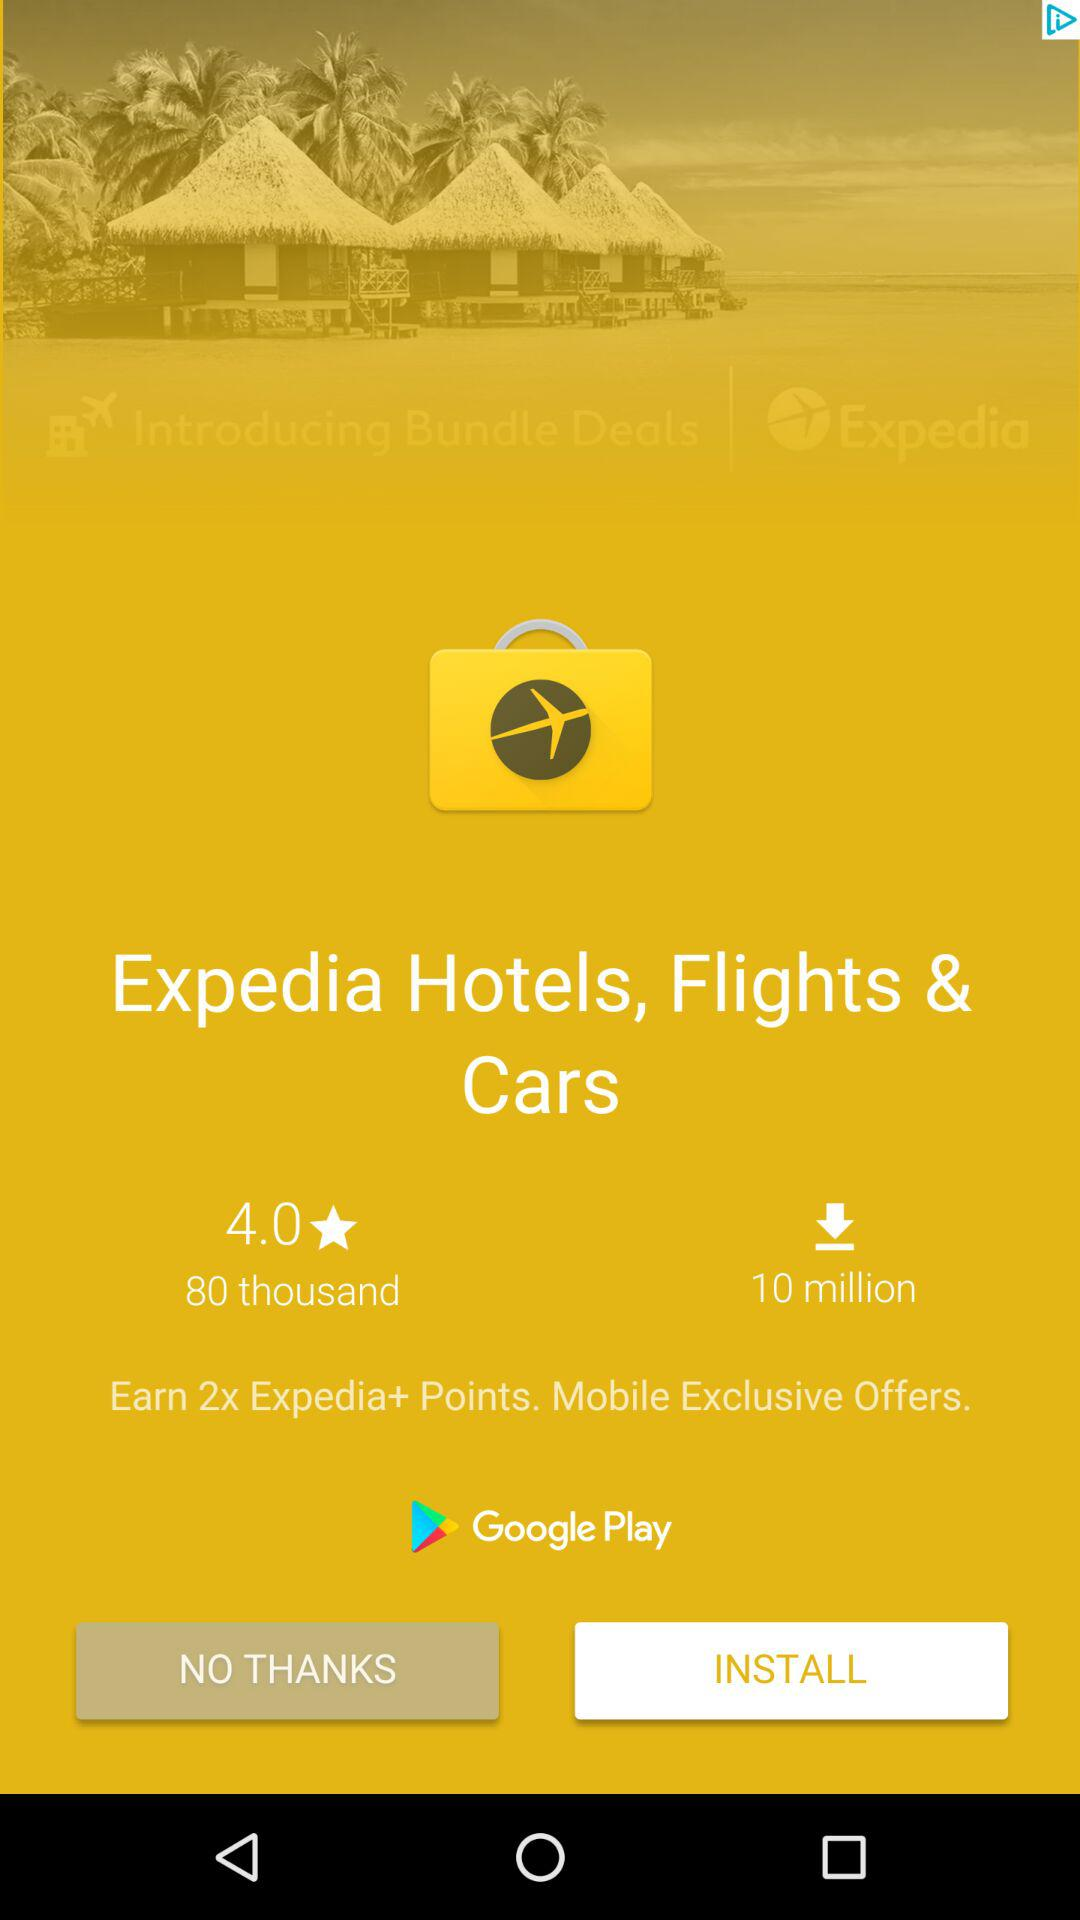How many more Expedia+ points can you earn by using the app than by using the website?
Answer the question using a single word or phrase. 2x 